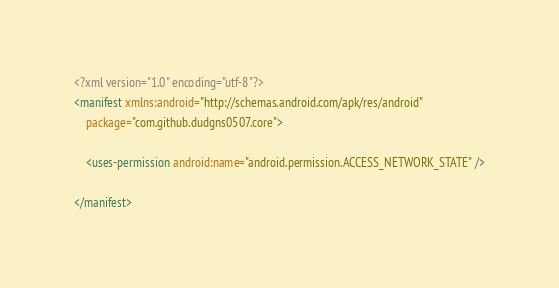Convert code to text. <code><loc_0><loc_0><loc_500><loc_500><_XML_><?xml version="1.0" encoding="utf-8"?>
<manifest xmlns:android="http://schemas.android.com/apk/res/android"
    package="com.github.dudgns0507.core">

    <uses-permission android:name="android.permission.ACCESS_NETWORK_STATE" />

</manifest></code> 